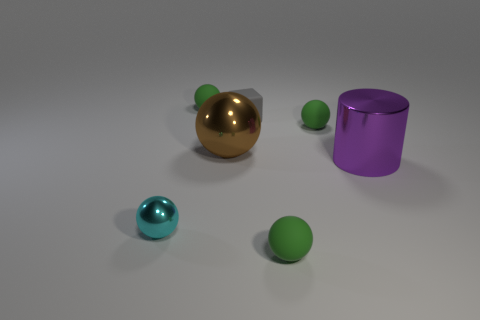How many green spheres must be subtracted to get 1 green spheres? 2 Subtract all green cylinders. How many green balls are left? 3 Subtract 3 spheres. How many spheres are left? 2 Subtract all cyan balls. How many balls are left? 4 Subtract all cyan shiny balls. How many balls are left? 4 Subtract all brown balls. Subtract all purple blocks. How many balls are left? 4 Add 3 purple metal blocks. How many objects exist? 10 Subtract all blocks. How many objects are left? 6 Subtract 0 gray cylinders. How many objects are left? 7 Subtract all purple cylinders. Subtract all small brown balls. How many objects are left? 6 